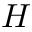<formula> <loc_0><loc_0><loc_500><loc_500>H</formula> 